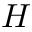<formula> <loc_0><loc_0><loc_500><loc_500>H</formula> 